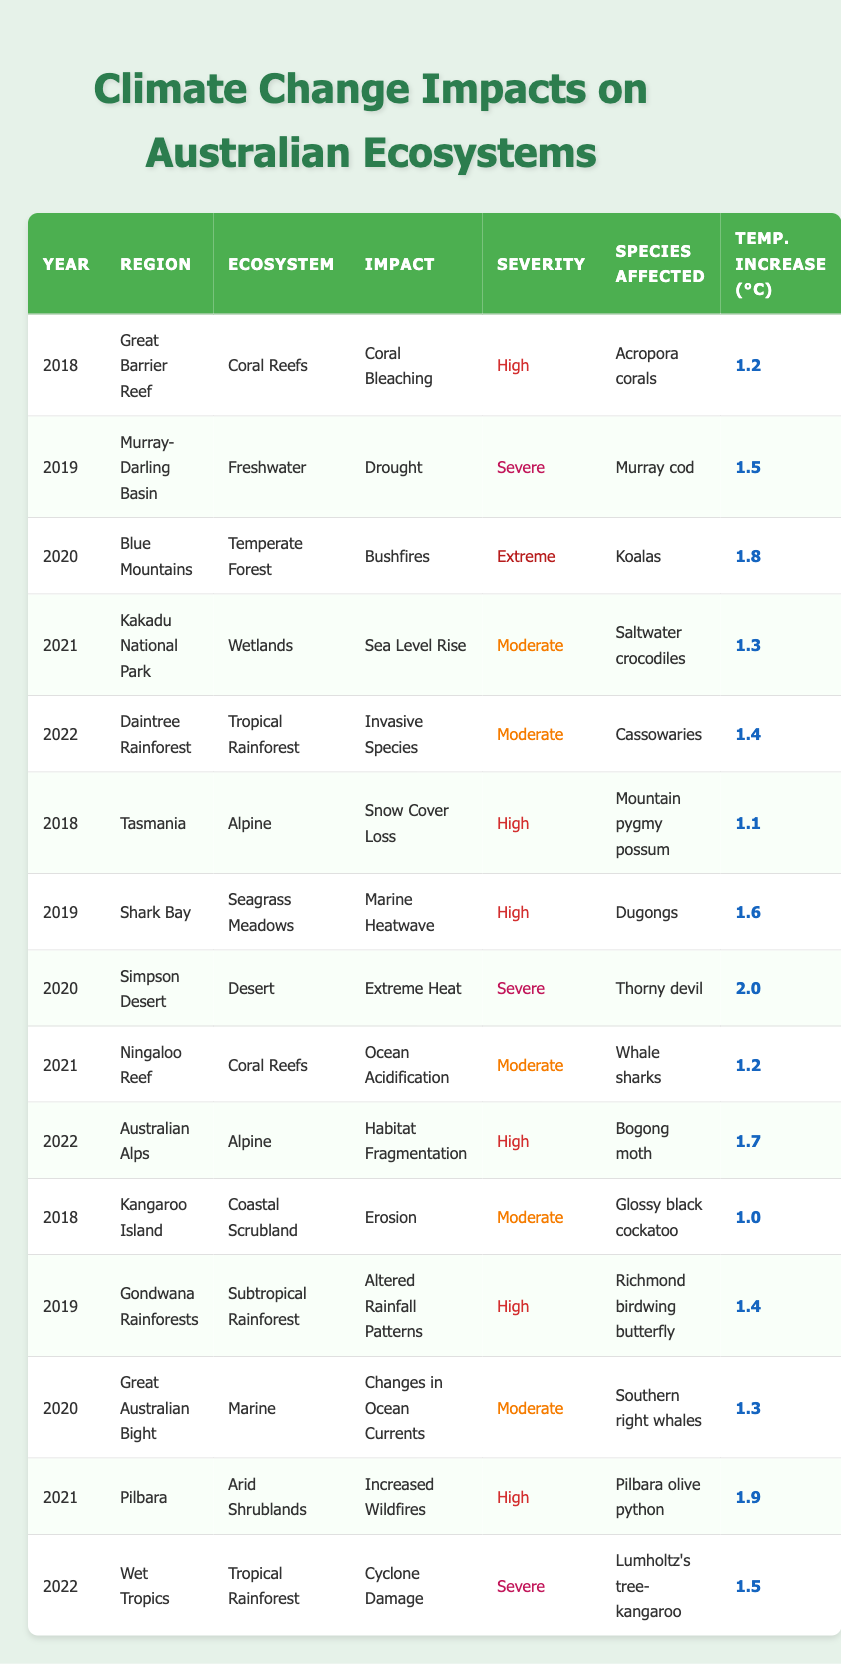What is the impact recorded in the Great Barrier Reef for the year 2018? The table shows that the impact recorded in the Great Barrier Reef for the year 2018 is Coral Bleaching.
Answer: Coral Bleaching In which year did the Blue Mountains experience extreme bushfires? From the table, the Blue Mountains experienced extreme bushfires in the year 2020.
Answer: 2020 Is the temperature increase associated with the impact on Southern right whales in the Great Australian Bight higher than 1.4°C? By checking the data for Southern right whales in the Great Australian Bight, the recorded temperature increase is 1.3°C, which is not higher than 1.4°C.
Answer: No How many different ecosystems are affected by severe impacts from climate change in 2022? Looking through the table for the year 2022, the severe impacts are reported for the Wet Tropics (Cyclone Damage) and the Murray-Darling Basin (Drought), thus there are two ecosystems affected by severe impacts.
Answer: 2 What is the average temperature increase for all instances of severe impacts across the provided years? To find the average, we first identify the severe impacts: Murray-Darling Basin (1.5°C), Simpson Desert (2.0°C), and Wet Tropics (1.5°C). Their sum is 1.5 + 2.0 + 1.5 = 5.0°C. With three data points, the average is 5.0°C divided by 3, which equals approximately 1.67°C.
Answer: 1.67°C Which region reported the highest severity of impact in the year 2020, and what was the impact? By checking the year 2020 in the table, the Blue Mountains reported the highest severity of impact classified as Extreme with the impact being Bushfires.
Answer: Blue Mountains, Bushfires What is the species affected by invasive species in the Daintree Rainforest for the year 2022? The table indicates that the species affected by invasive species in the Daintree Rainforest in 2022 is the Cassowaries.
Answer: Cassowaries Was ocean acidification noted in any year in the Ningaloo Reef? According to the data, ocean acidification was recorded in the Ningaloo Reef in the year 2021. Therefore, the statement is true.
Answer: Yes In which year and region was snow cover loss reported with a high severity, and which species was affected? The table lists Tasmania in the year 2018 as having reported snow cover loss with a high severity. The affected species is the Mountain pygmy possum.
Answer: 2018, Tasmania, Mountain pygmy possum 